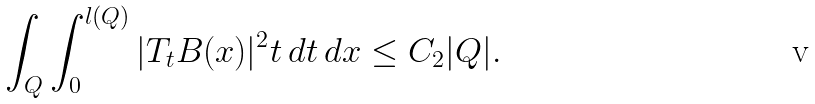<formula> <loc_0><loc_0><loc_500><loc_500>\int _ { Q } \int _ { 0 } ^ { l ( Q ) } | T _ { t } B ( x ) | ^ { 2 } t \, d t \, d x \leq C _ { 2 } | Q | .</formula> 